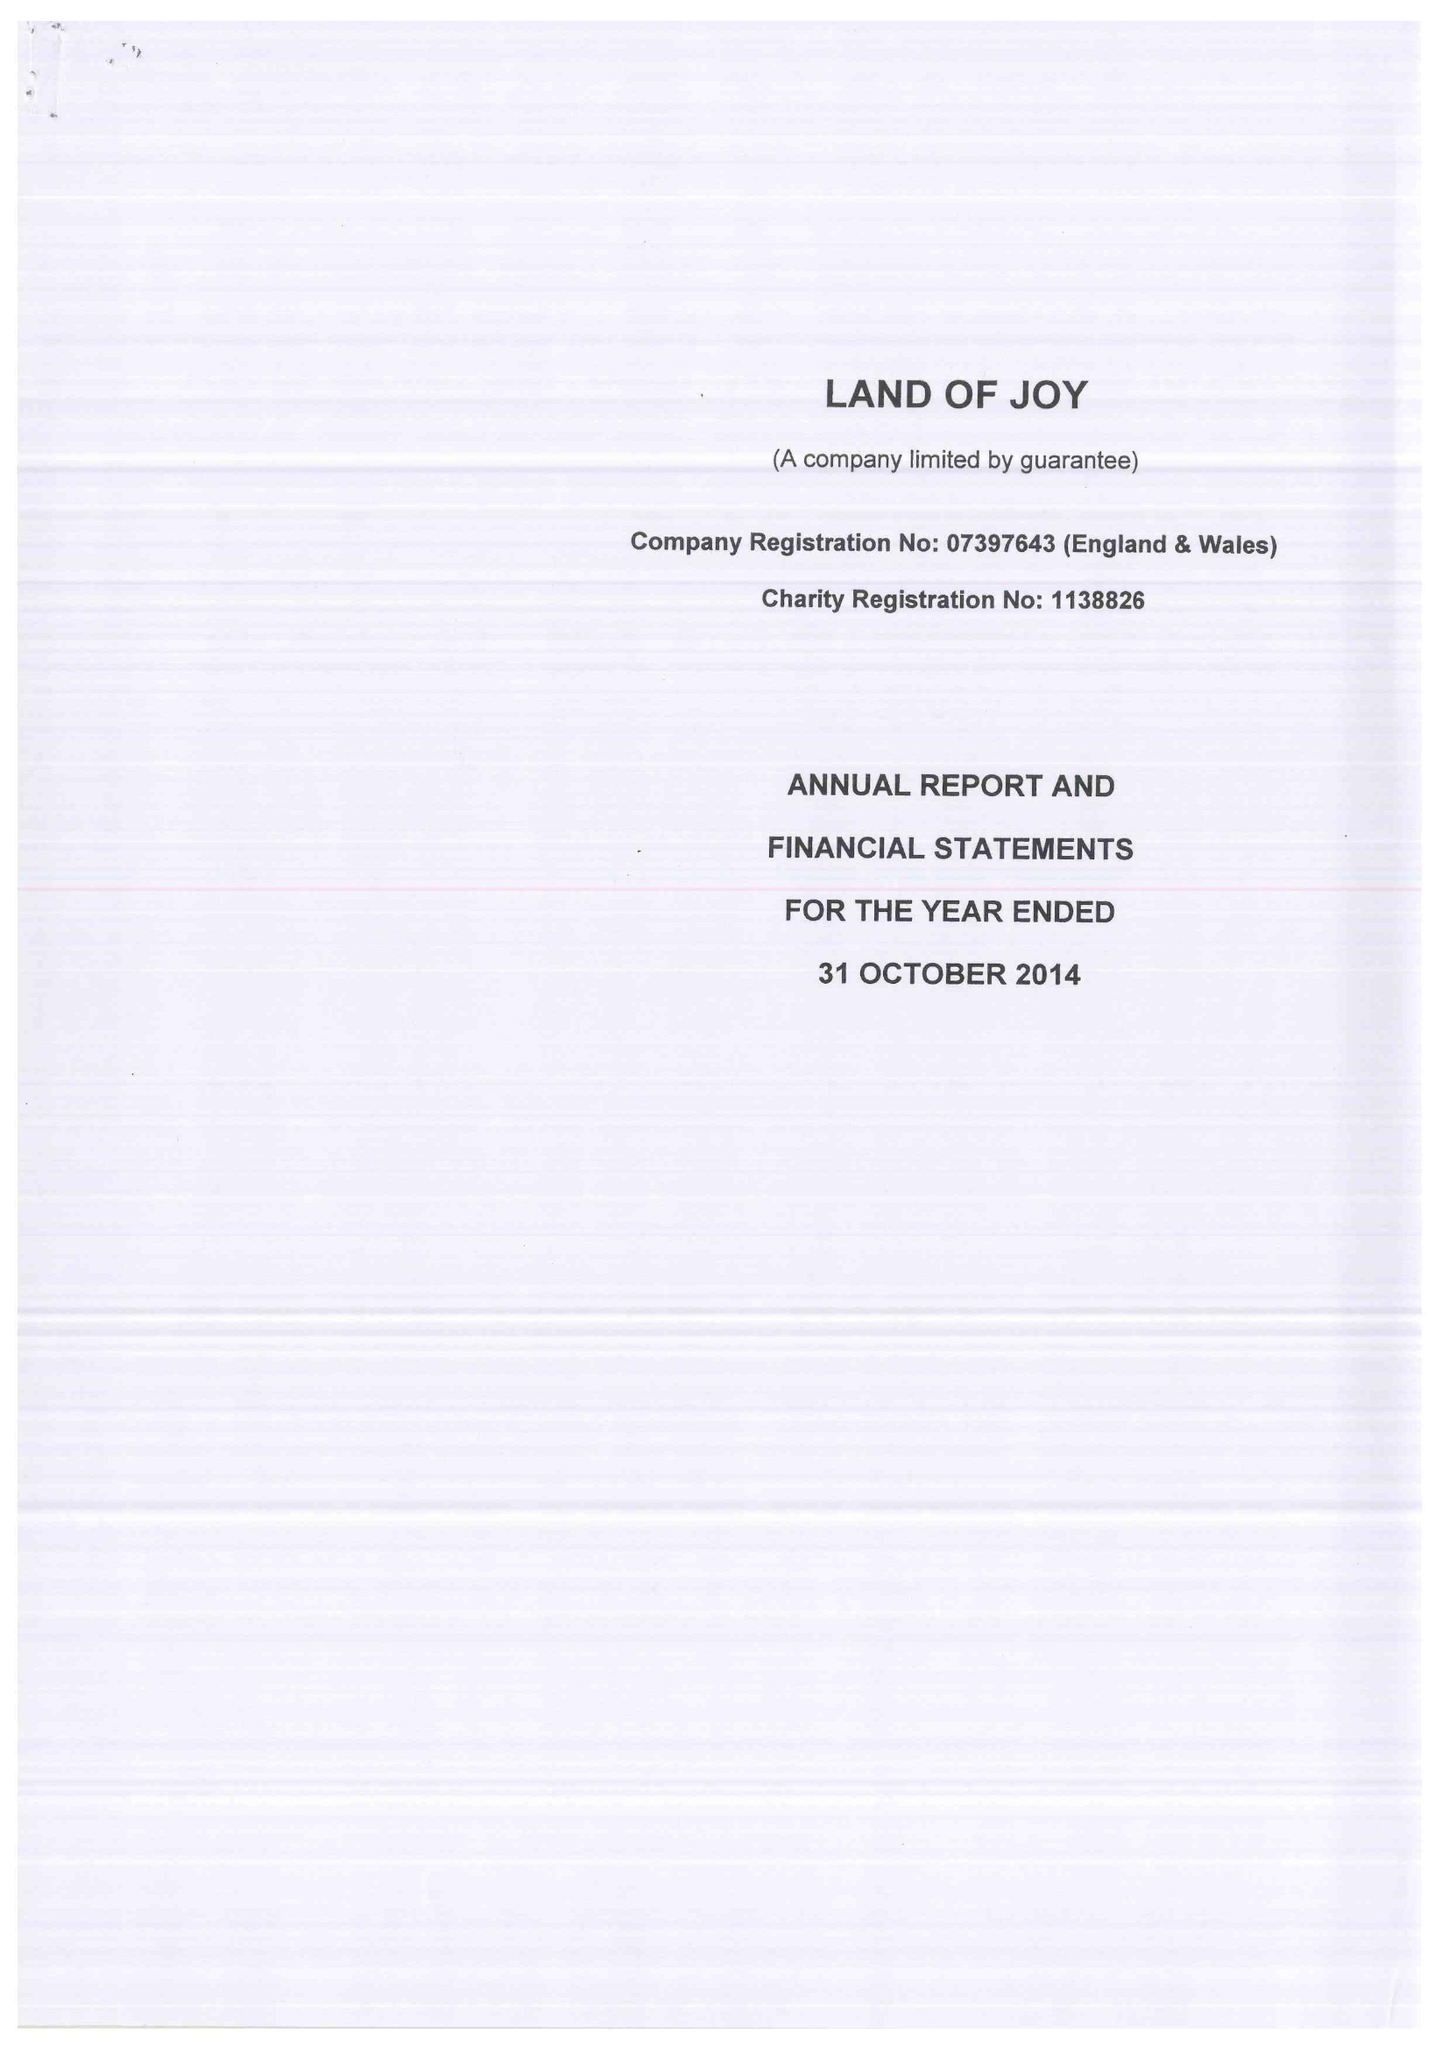What is the value for the charity_number?
Answer the question using a single word or phrase. 1138826 